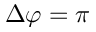<formula> <loc_0><loc_0><loc_500><loc_500>\Delta \varphi = \pi</formula> 